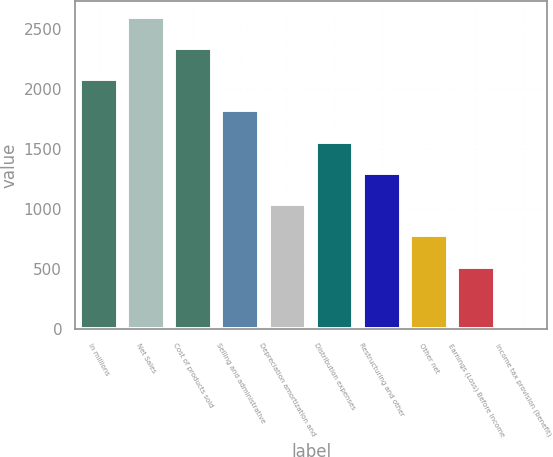Convert chart. <chart><loc_0><loc_0><loc_500><loc_500><bar_chart><fcel>In millions<fcel>Net Sales<fcel>Cost of products sold<fcel>Selling and administrative<fcel>Depreciation amortization and<fcel>Distribution expenses<fcel>Restructuring and other<fcel>Other net<fcel>Earnings (Loss) Before Income<fcel>Income tax provision (benefit)<nl><fcel>2083.4<fcel>2604<fcel>2343.7<fcel>1823.1<fcel>1042.2<fcel>1562.8<fcel>1302.5<fcel>781.9<fcel>521.6<fcel>1<nl></chart> 